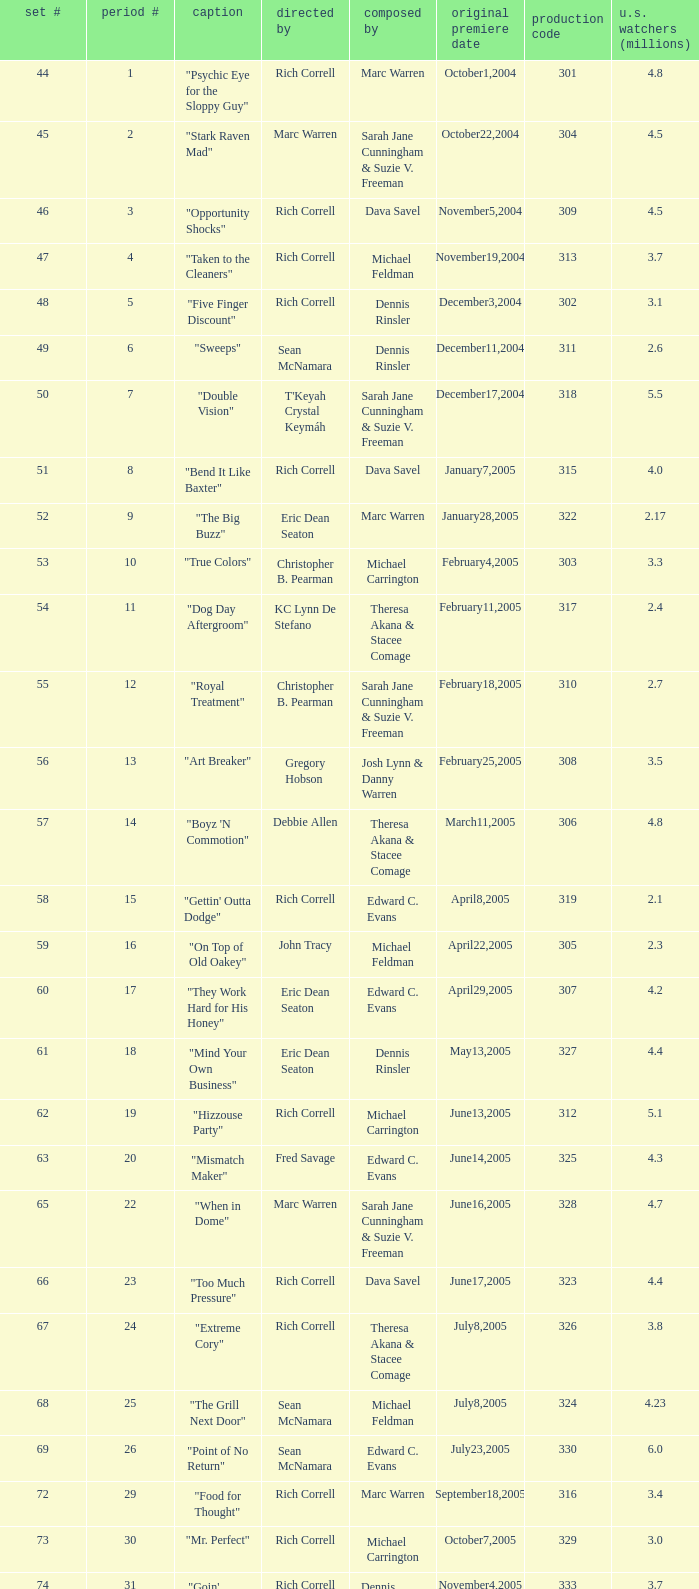What number episode in the season had a production code of 334? 32.0. 